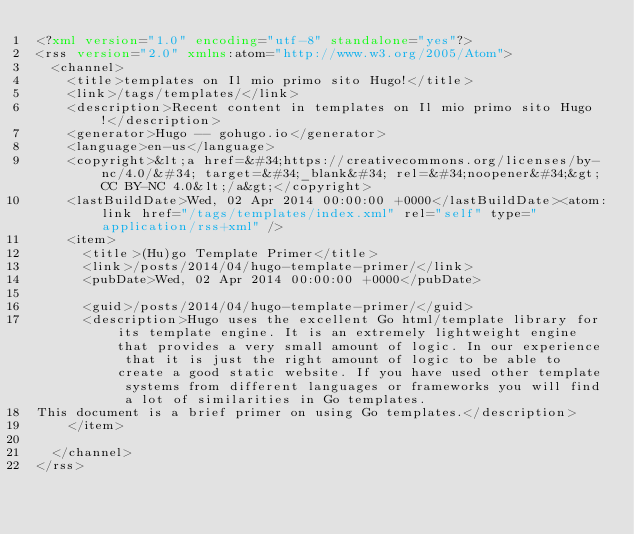<code> <loc_0><loc_0><loc_500><loc_500><_XML_><?xml version="1.0" encoding="utf-8" standalone="yes"?>
<rss version="2.0" xmlns:atom="http://www.w3.org/2005/Atom">
  <channel>
    <title>templates on Il mio primo sito Hugo!</title>
    <link>/tags/templates/</link>
    <description>Recent content in templates on Il mio primo sito Hugo!</description>
    <generator>Hugo -- gohugo.io</generator>
    <language>en-us</language>
    <copyright>&lt;a href=&#34;https://creativecommons.org/licenses/by-nc/4.0/&#34; target=&#34;_blank&#34; rel=&#34;noopener&#34;&gt;CC BY-NC 4.0&lt;/a&gt;</copyright>
    <lastBuildDate>Wed, 02 Apr 2014 00:00:00 +0000</lastBuildDate><atom:link href="/tags/templates/index.xml" rel="self" type="application/rss+xml" />
    <item>
      <title>(Hu)go Template Primer</title>
      <link>/posts/2014/04/hugo-template-primer/</link>
      <pubDate>Wed, 02 Apr 2014 00:00:00 +0000</pubDate>
      
      <guid>/posts/2014/04/hugo-template-primer/</guid>
      <description>Hugo uses the excellent Go html/template library for its template engine. It is an extremely lightweight engine that provides a very small amount of logic. In our experience that it is just the right amount of logic to be able to create a good static website. If you have used other template systems from different languages or frameworks you will find a lot of similarities in Go templates.
This document is a brief primer on using Go templates.</description>
    </item>
    
  </channel>
</rss>
</code> 